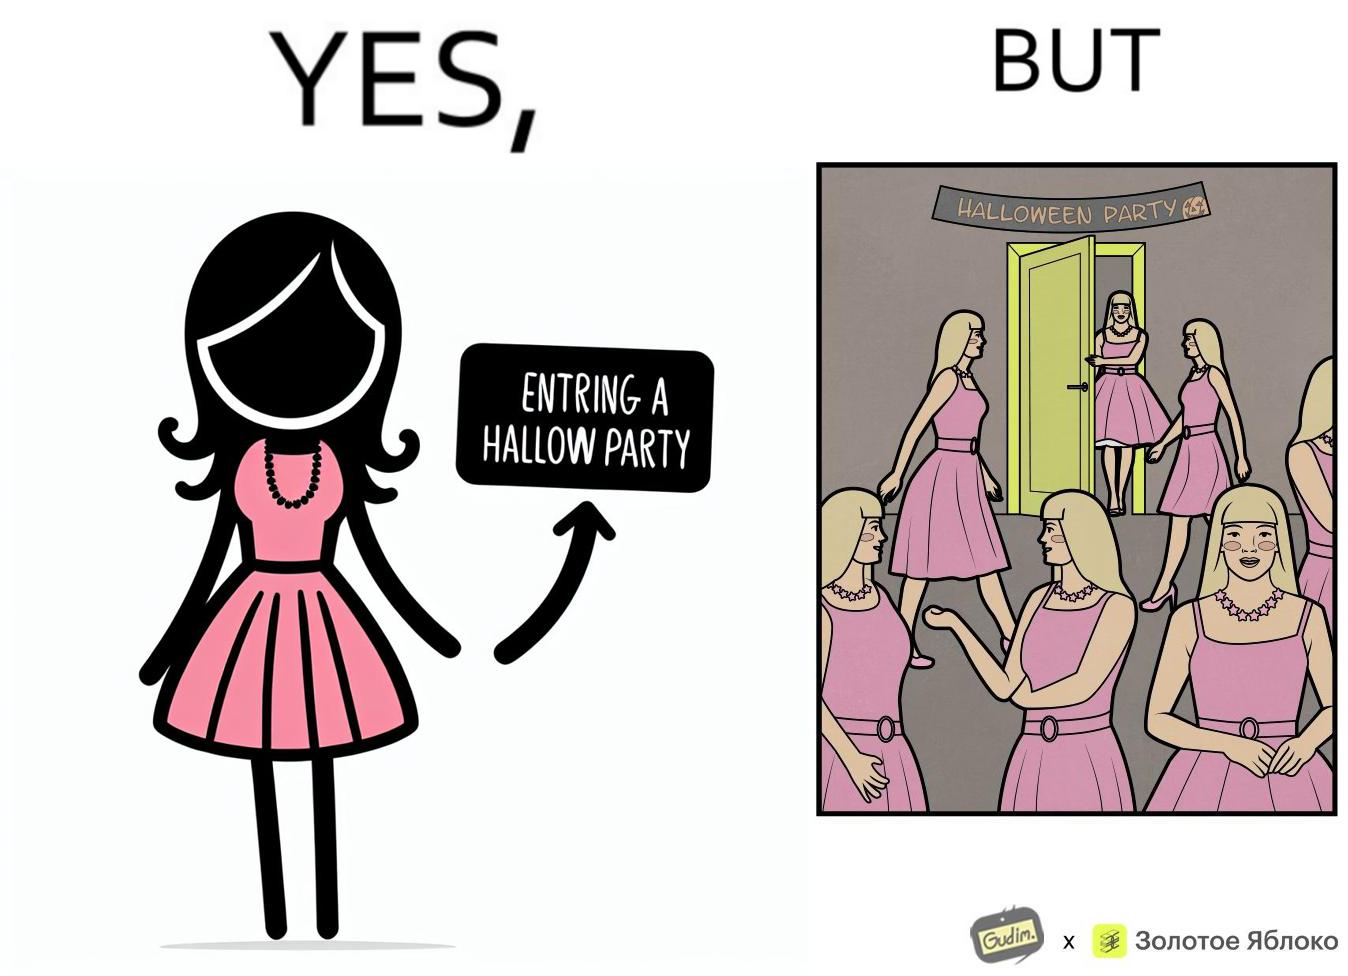Describe the contrast between the left and right parts of this image. In the left part of the image: A woman entering a Halloween Party wearing a pink top and skirt with a necklace around the neck as costume. In the right part of the image: A person entering a Halloween Party wearing a pink top and skirt along with a necklace around the neck as costume, and others in the room have the same costume. 